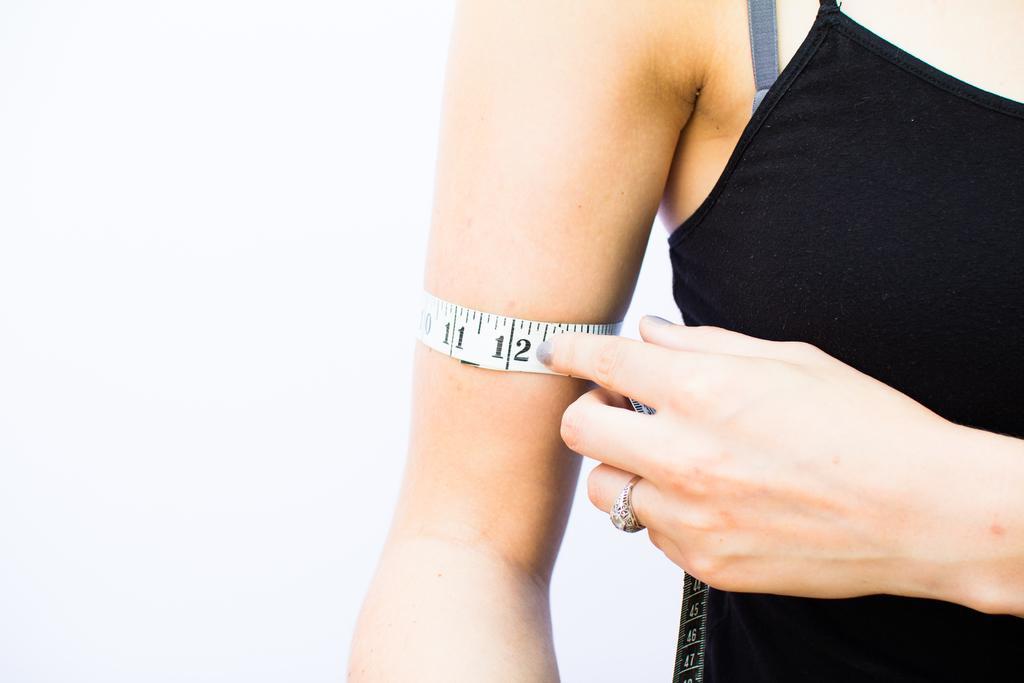Please provide a concise description of this image. In the image we can see a woman wearing clothes and a finger ring. This is a measuring tape. 